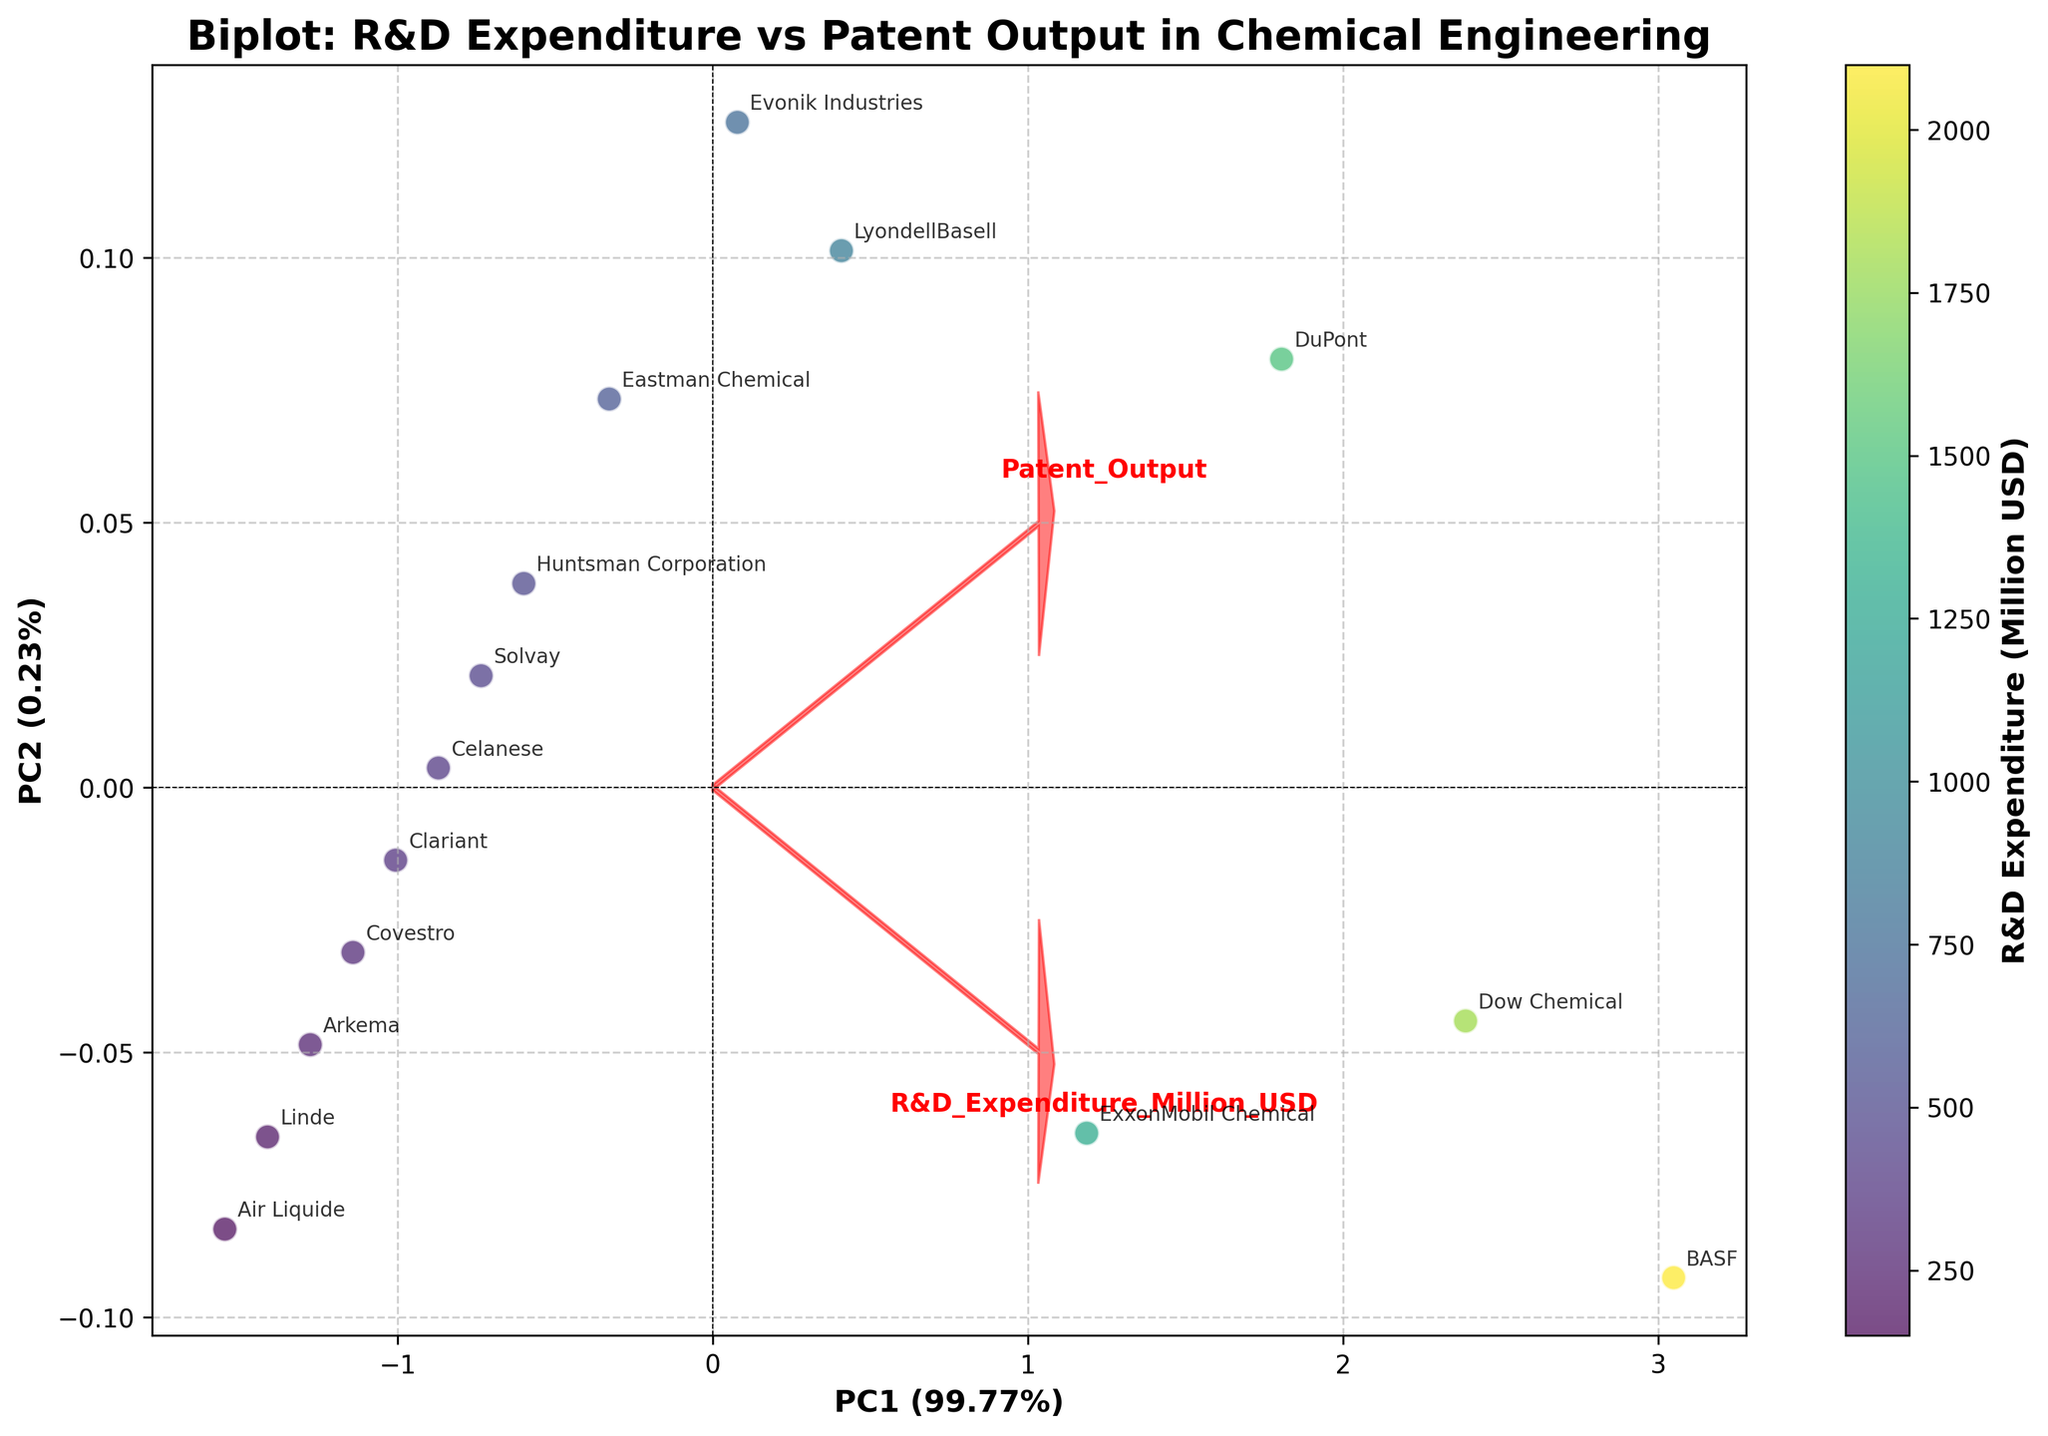What is the title of the biplot? The title is usually located at the top of the plot and describes what the biplot represents.
Answer: Biplot: R&D Expenditure vs Patent Output in Chemical Engineering How many data points are shown in the biplot? Each data point represents a company in the chemical engineering sector, plotted based on their scores from PCA. Counting the annotated points on the plot gives the number of data points.
Answer: 15 What do the color gradients represent in the scatter points? The color gradient is explained in the color bar on the right side of the plot. The label of the color bar indicates what the color gradient signifies.
Answer: R&D Expenditure (Million USD) Which two companies are closest to each other in the biplot? By visually inspecting the plot, you can see which two companies' points are closest to each other in terms of Euclidean distance on the biplot.
Answer: Covestro and Clariant In which direction do the loadings arrows point, and what does it indicate? The arrows point from the origin towards the data variable; the direction indicates how much the variable influences the principal components. By following the red arrows, you can see where the variables are significantly contributing.
Answer: Positive PC1 for both R&D Expenditure and Patent Output Which company has the highest R&D expenditure based on the color intensity of the points? The darkest color intensity on the color gradient represents the highest R&D expenditure. Checking the data point with the darkest color identifies the company.
Answer: BASF What are the explained variances of PC1 and PC2 given in the biplot? The explained variances of the principal components are usually found in the axis labels of PC1 and PC2. They are typically given as percentages.
Answer: PC1: 94.43%, PC2: 2.93% How are R&D expenditure and patent output correlated based on the direction of the loadings? If the loadings for R&D expenditure and patent output are in similar directions, it indicates a positive correlation. Both arrows pointing in the same general direction in the biplot would show this relationship.
Answer: Positively correlated Identify the companies located in the first quadrant of the biplot. The first quadrant is the area where both PC1 and PC2 are positive. The companies located in this region would be above and to the right of the origin.
Answer: BASF, Dow Chemical Which company is an outlier in terms of patent output compared to its R&D expenditure, based on the biplot's visual information? An outlier would be a company located far from the general cluster or where the R&D expenditure does not correspond to the patent output pattern.
Answer: Linde 